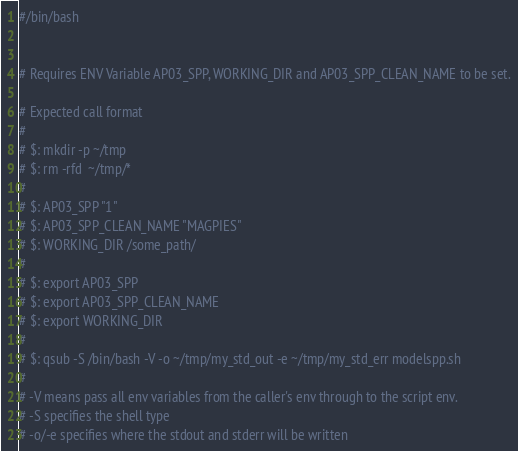<code> <loc_0><loc_0><loc_500><loc_500><_Bash_>#/bin/bash


# Requires ENV Variable AP03_SPP, WORKING_DIR and AP03_SPP_CLEAN_NAME to be set.

# Expected call format
#
# $: mkdir -p ~/tmp
# $: rm -rfd  ~/tmp/*
#
# $: AP03_SPP "1"
# $: AP03_SPP_CLEAN_NAME "MAGPIES"
# $: WORKING_DIR /some_path/
#
# $: export AP03_SPP
# $: export AP03_SPP_CLEAN_NAME
# $: export WORKING_DIR
#
# $: qsub -S /bin/bash -V -o ~/tmp/my_std_out -e ~/tmp/my_std_err modelspp.sh
#
# -V means pass all env variables from the caller's env through to the script env.
# -S specifies the shell type
# -o/-e specifies where the stdout and stderr will be written
</code> 